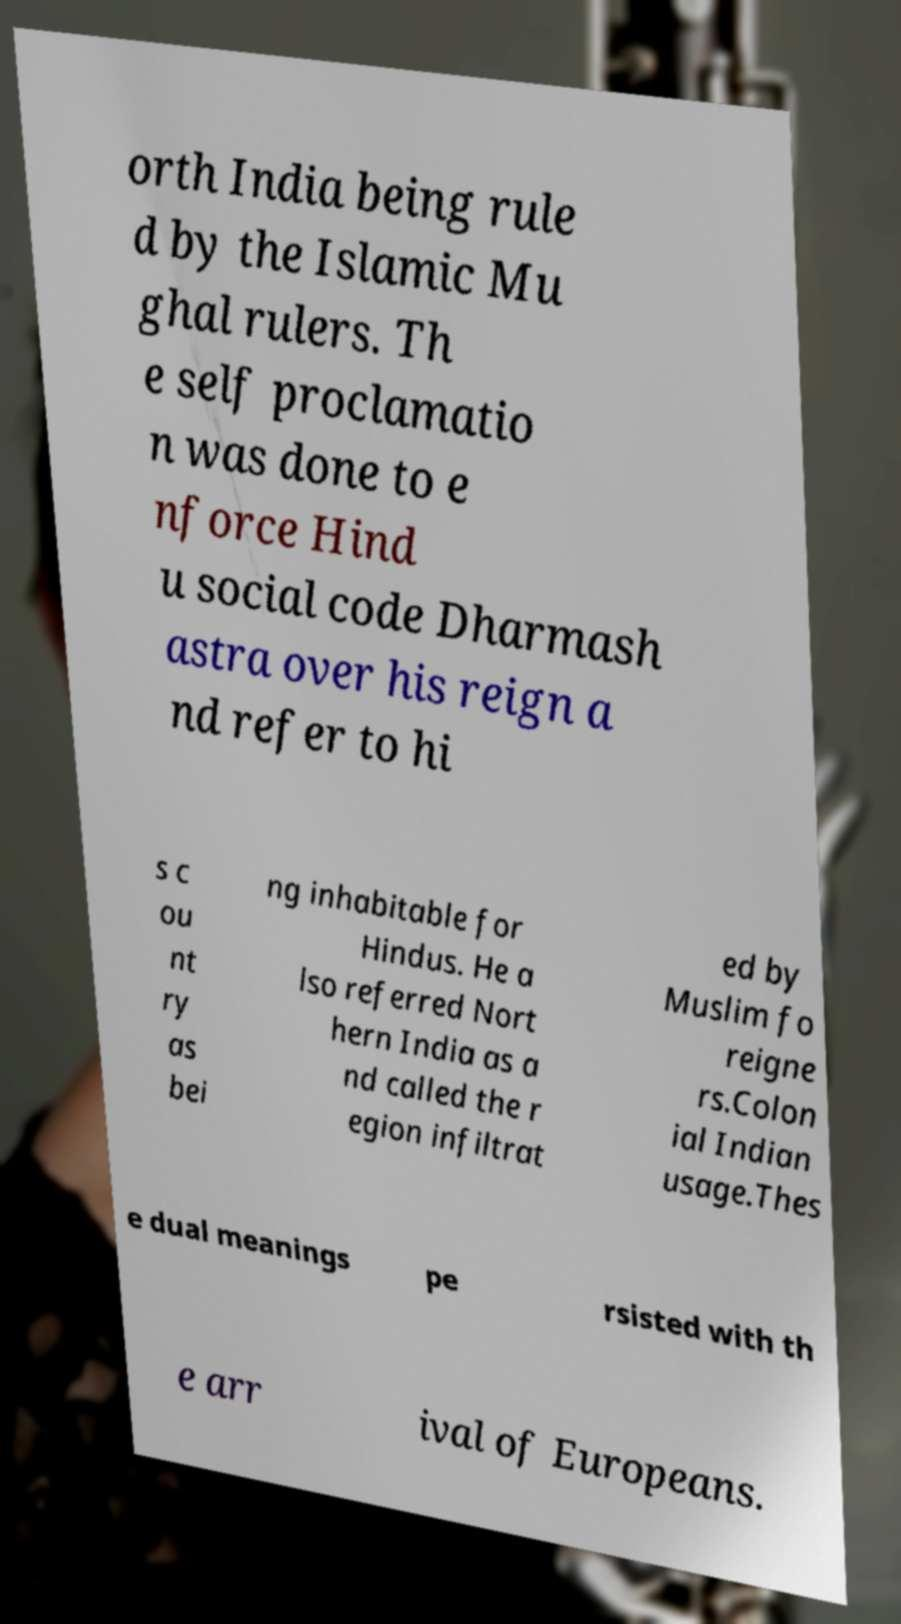Could you assist in decoding the text presented in this image and type it out clearly? orth India being rule d by the Islamic Mu ghal rulers. Th e self proclamatio n was done to e nforce Hind u social code Dharmash astra over his reign a nd refer to hi s c ou nt ry as bei ng inhabitable for Hindus. He a lso referred Nort hern India as a nd called the r egion infiltrat ed by Muslim fo reigne rs.Colon ial Indian usage.Thes e dual meanings pe rsisted with th e arr ival of Europeans. 